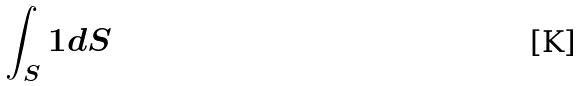Convert formula to latex. <formula><loc_0><loc_0><loc_500><loc_500>\int _ { S } 1 d S</formula> 